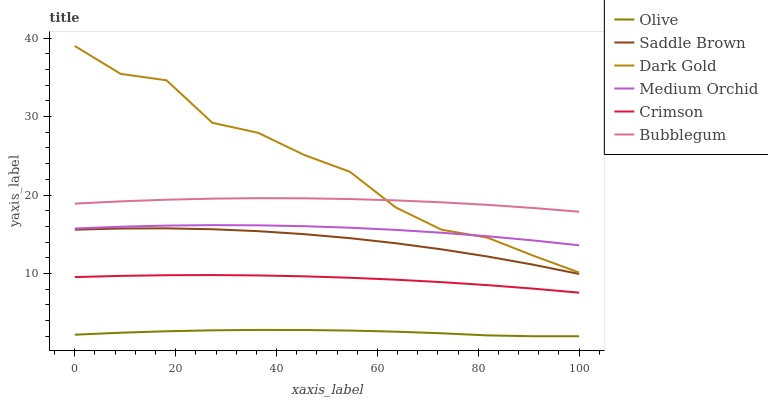Does Medium Orchid have the minimum area under the curve?
Answer yes or no. No. Does Medium Orchid have the maximum area under the curve?
Answer yes or no. No. Is Medium Orchid the smoothest?
Answer yes or no. No. Is Medium Orchid the roughest?
Answer yes or no. No. Does Medium Orchid have the lowest value?
Answer yes or no. No. Does Medium Orchid have the highest value?
Answer yes or no. No. Is Olive less than Saddle Brown?
Answer yes or no. Yes. Is Dark Gold greater than Crimson?
Answer yes or no. Yes. Does Olive intersect Saddle Brown?
Answer yes or no. No. 